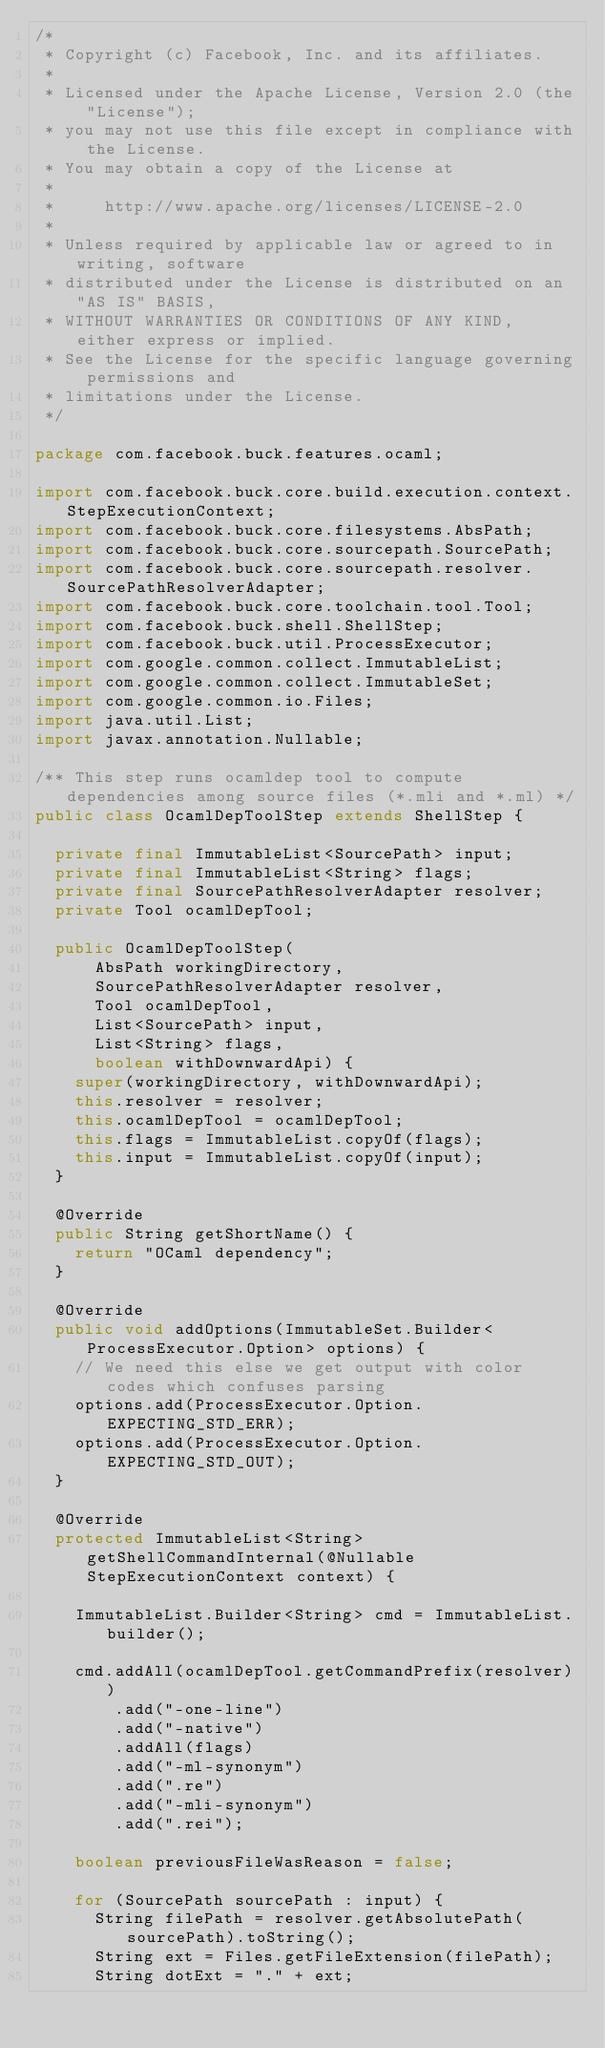Convert code to text. <code><loc_0><loc_0><loc_500><loc_500><_Java_>/*
 * Copyright (c) Facebook, Inc. and its affiliates.
 *
 * Licensed under the Apache License, Version 2.0 (the "License");
 * you may not use this file except in compliance with the License.
 * You may obtain a copy of the License at
 *
 *     http://www.apache.org/licenses/LICENSE-2.0
 *
 * Unless required by applicable law or agreed to in writing, software
 * distributed under the License is distributed on an "AS IS" BASIS,
 * WITHOUT WARRANTIES OR CONDITIONS OF ANY KIND, either express or implied.
 * See the License for the specific language governing permissions and
 * limitations under the License.
 */

package com.facebook.buck.features.ocaml;

import com.facebook.buck.core.build.execution.context.StepExecutionContext;
import com.facebook.buck.core.filesystems.AbsPath;
import com.facebook.buck.core.sourcepath.SourcePath;
import com.facebook.buck.core.sourcepath.resolver.SourcePathResolverAdapter;
import com.facebook.buck.core.toolchain.tool.Tool;
import com.facebook.buck.shell.ShellStep;
import com.facebook.buck.util.ProcessExecutor;
import com.google.common.collect.ImmutableList;
import com.google.common.collect.ImmutableSet;
import com.google.common.io.Files;
import java.util.List;
import javax.annotation.Nullable;

/** This step runs ocamldep tool to compute dependencies among source files (*.mli and *.ml) */
public class OcamlDepToolStep extends ShellStep {

  private final ImmutableList<SourcePath> input;
  private final ImmutableList<String> flags;
  private final SourcePathResolverAdapter resolver;
  private Tool ocamlDepTool;

  public OcamlDepToolStep(
      AbsPath workingDirectory,
      SourcePathResolverAdapter resolver,
      Tool ocamlDepTool,
      List<SourcePath> input,
      List<String> flags,
      boolean withDownwardApi) {
    super(workingDirectory, withDownwardApi);
    this.resolver = resolver;
    this.ocamlDepTool = ocamlDepTool;
    this.flags = ImmutableList.copyOf(flags);
    this.input = ImmutableList.copyOf(input);
  }

  @Override
  public String getShortName() {
    return "OCaml dependency";
  }

  @Override
  public void addOptions(ImmutableSet.Builder<ProcessExecutor.Option> options) {
    // We need this else we get output with color codes which confuses parsing
    options.add(ProcessExecutor.Option.EXPECTING_STD_ERR);
    options.add(ProcessExecutor.Option.EXPECTING_STD_OUT);
  }

  @Override
  protected ImmutableList<String> getShellCommandInternal(@Nullable StepExecutionContext context) {

    ImmutableList.Builder<String> cmd = ImmutableList.builder();

    cmd.addAll(ocamlDepTool.getCommandPrefix(resolver))
        .add("-one-line")
        .add("-native")
        .addAll(flags)
        .add("-ml-synonym")
        .add(".re")
        .add("-mli-synonym")
        .add(".rei");

    boolean previousFileWasReason = false;

    for (SourcePath sourcePath : input) {
      String filePath = resolver.getAbsolutePath(sourcePath).toString();
      String ext = Files.getFileExtension(filePath);
      String dotExt = "." + ext;
</code> 